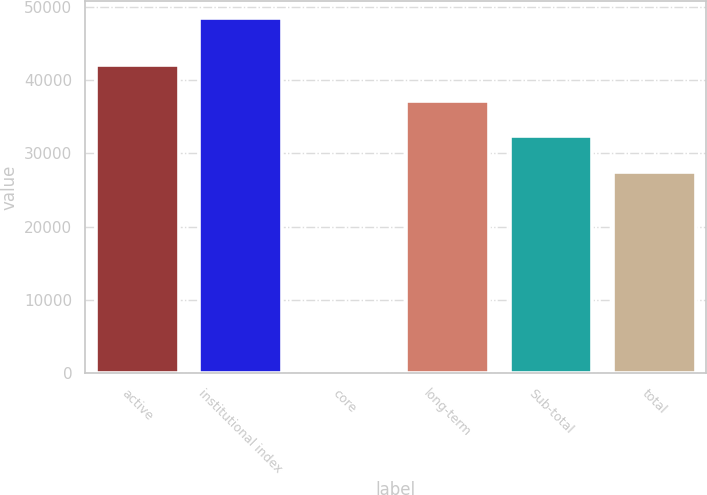<chart> <loc_0><loc_0><loc_500><loc_500><bar_chart><fcel>active<fcel>institutional index<fcel>core<fcel>long-term<fcel>Sub-total<fcel>total<nl><fcel>41979.9<fcel>48402<fcel>179<fcel>37157.6<fcel>32335.3<fcel>27513<nl></chart> 